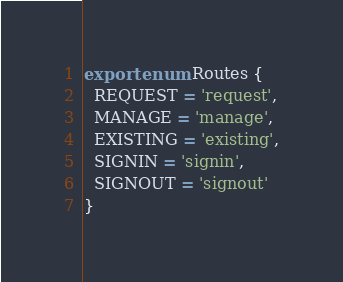Convert code to text. <code><loc_0><loc_0><loc_500><loc_500><_TypeScript_>export enum Routes {
  REQUEST = 'request',
  MANAGE = 'manage',
  EXISTING = 'existing',
  SIGNIN = 'signin',
  SIGNOUT = 'signout'
}
</code> 